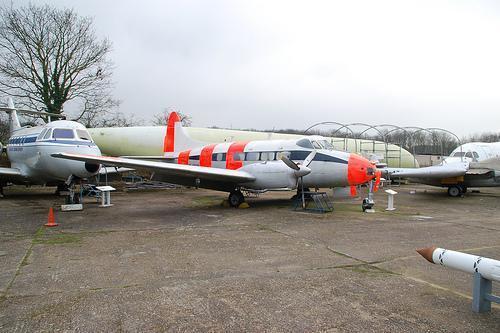How many planes are in the picture?
Give a very brief answer. 4. 